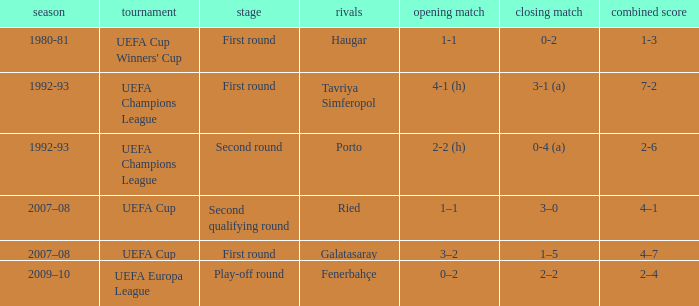 what's the 1st leg where opponents is galatasaray 3–2. 